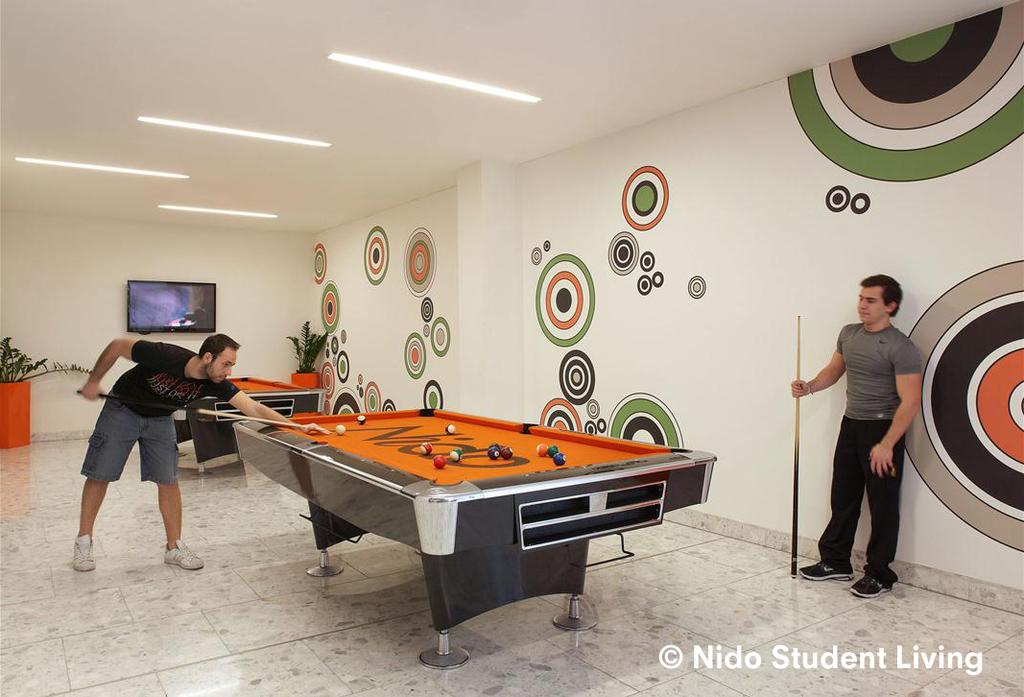How many people are present in the image? There are two men in the image. What activity are the men engaged in? The men are playing snooker, as there are two snooker tables in the image. Is there any electronic device visible in the image? Yes, there is a television on the wall in the image. What type of trick does the cat perform on the baseball field in the image? There is no cat or baseball field present in the image; it features two men playing snooker and a television on the wall. 